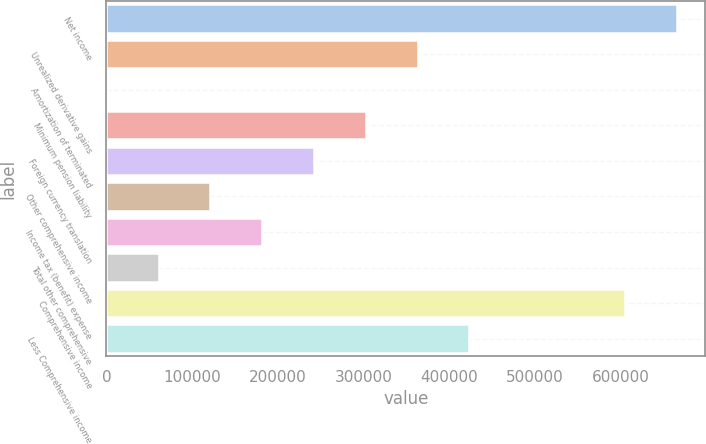Convert chart to OTSL. <chart><loc_0><loc_0><loc_500><loc_500><bar_chart><fcel>Net income<fcel>Unrealized derivative gains<fcel>Amortization of terminated<fcel>Minimum pension liability<fcel>Foreign currency translation<fcel>Other comprehensive income<fcel>Income tax (benefit) expense<fcel>Total other comprehensive<fcel>Comprehensive income<fcel>Less Comprehensive income<nl><fcel>665853<fcel>363132<fcel>336<fcel>302666<fcel>242200<fcel>121268<fcel>181734<fcel>60802<fcel>605387<fcel>423598<nl></chart> 